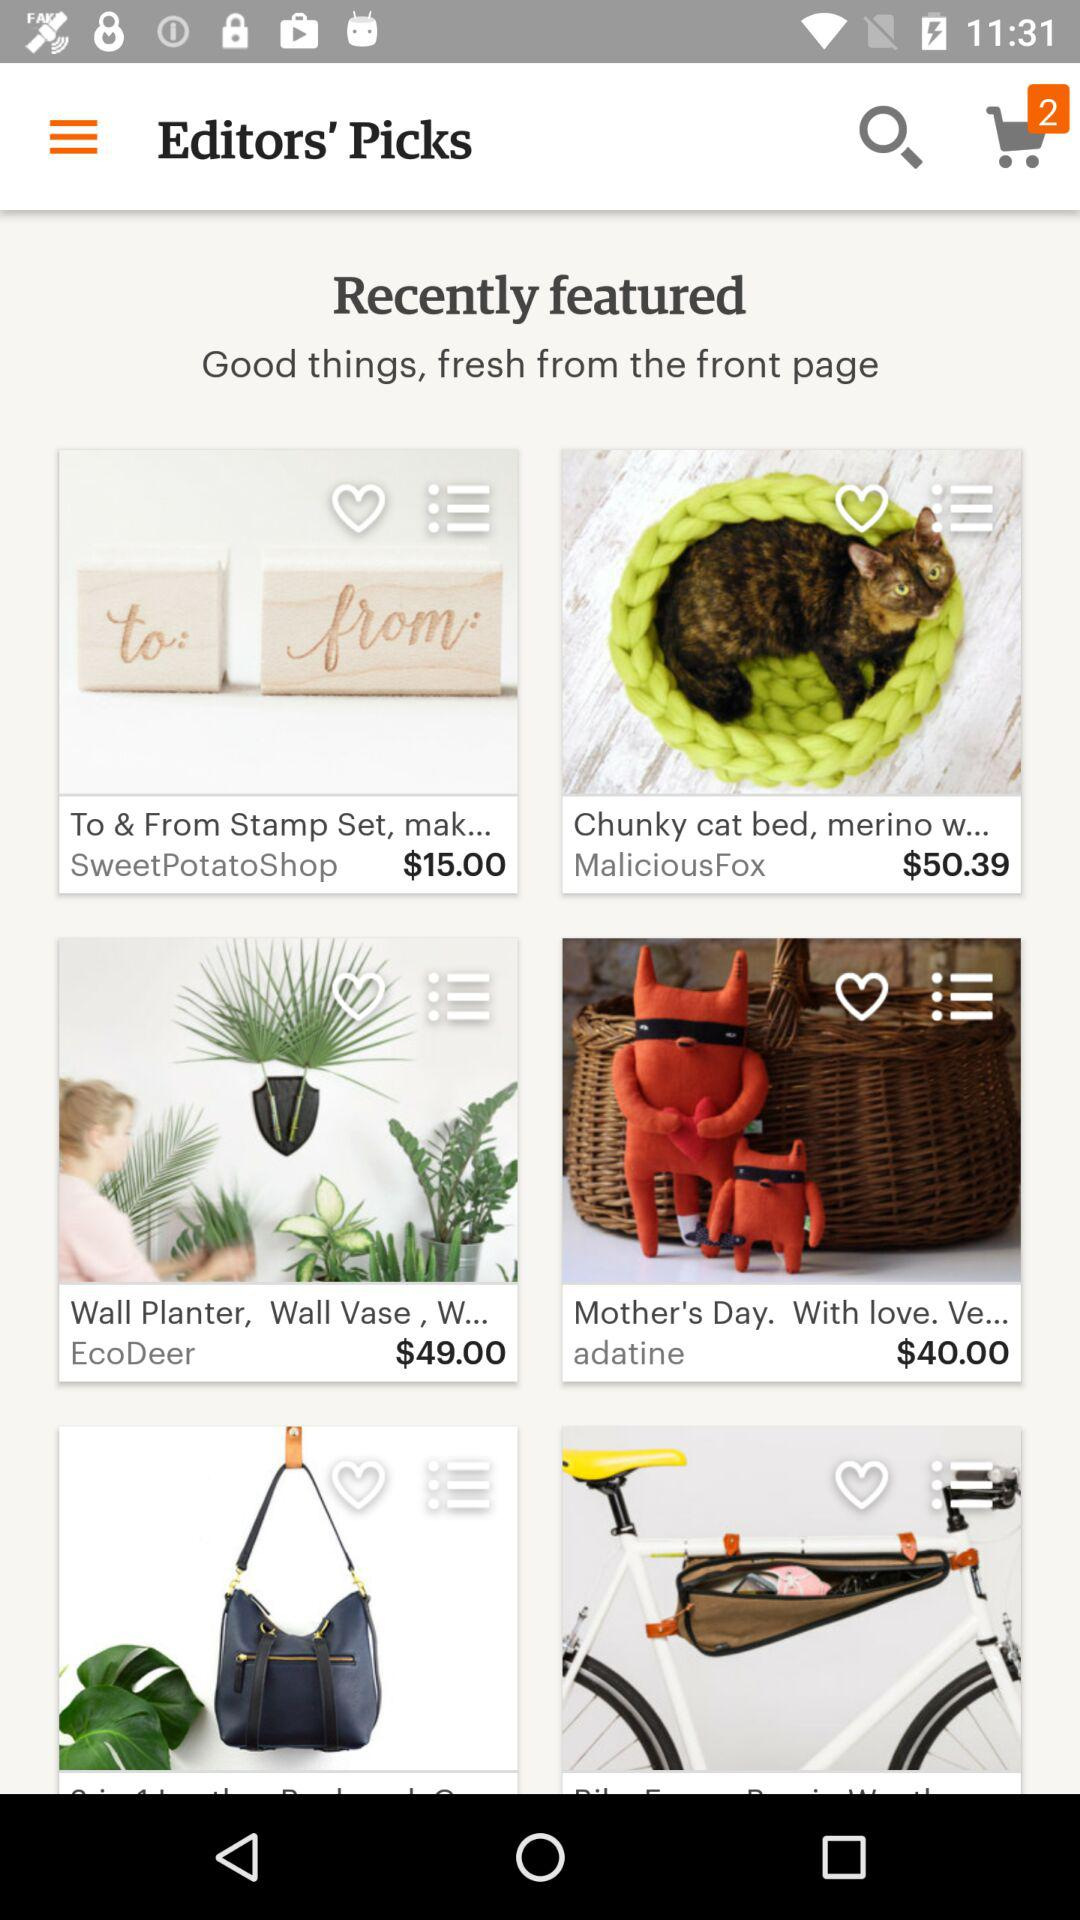What is the name of application?
When the provided information is insufficient, respond with <no answer>. <no answer> 